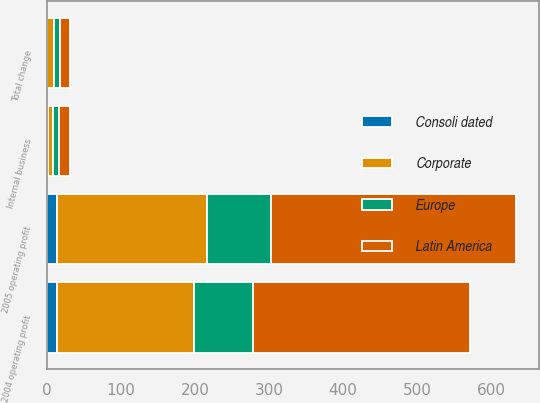<chart> <loc_0><loc_0><loc_500><loc_500><stacked_bar_chart><ecel><fcel>2005 operating profit<fcel>2004 operating profit<fcel>Internal business<fcel>Total change<nl><fcel>Consoli dated<fcel>14<fcel>14<fcel>2.4<fcel>0.9<nl><fcel>Latin America<fcel>330.7<fcel>292.3<fcel>14.9<fcel>13.1<nl><fcel>Corporate<fcel>202.8<fcel>185.4<fcel>6.6<fcel>9.4<nl><fcel>Europe<fcel>86<fcel>79.5<fcel>7.4<fcel>8.2<nl></chart> 